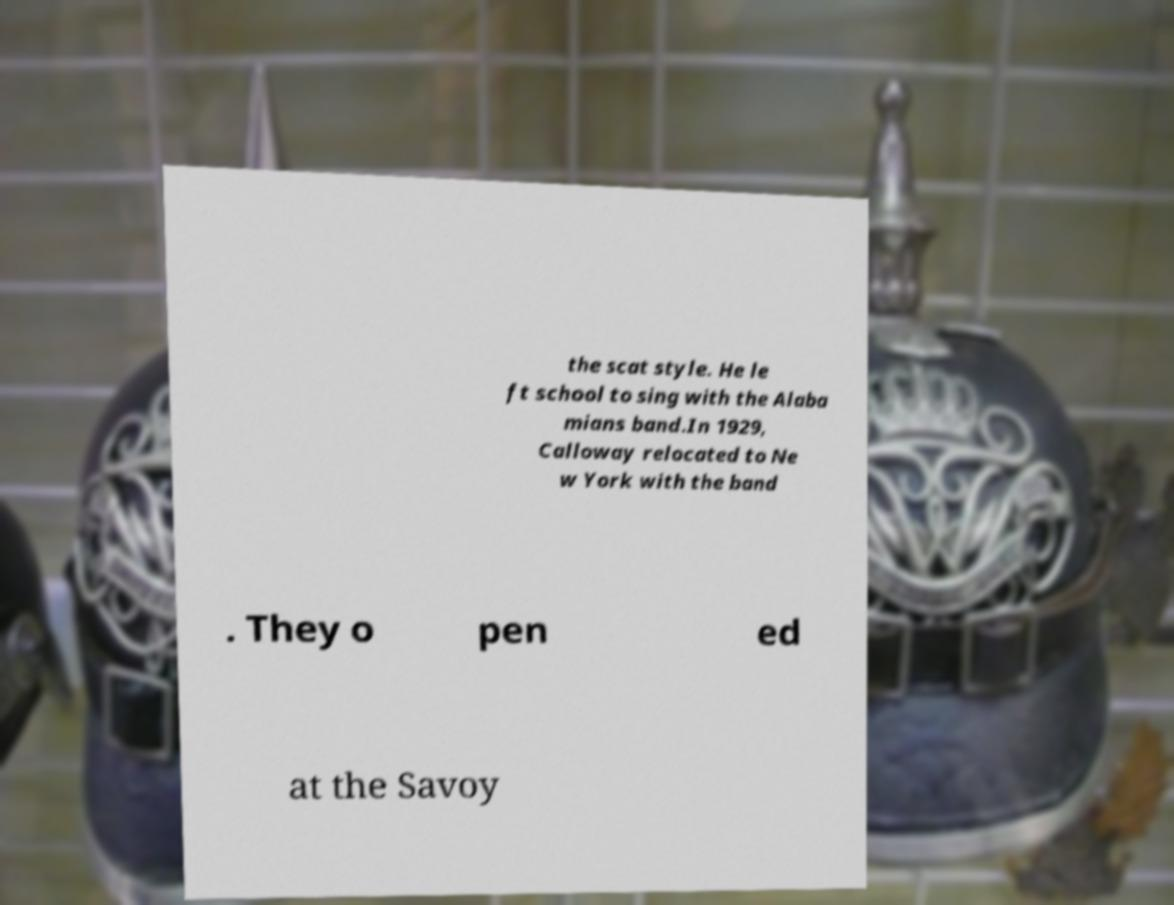I need the written content from this picture converted into text. Can you do that? the scat style. He le ft school to sing with the Alaba mians band.In 1929, Calloway relocated to Ne w York with the band . They o pen ed at the Savoy 